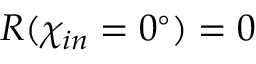<formula> <loc_0><loc_0><loc_500><loc_500>R ( \chi _ { i n } = 0 ^ { \circ } ) = 0</formula> 